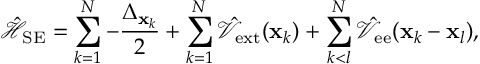Convert formula to latex. <formula><loc_0><loc_0><loc_500><loc_500>\hat { \mathcal { H } } _ { S E } = \sum _ { k = 1 } ^ { N } { - \frac { \Delta _ { { x } _ { k } } } { 2 } } + \sum _ { k = 1 } ^ { N } { \hat { \mathcal { V } } _ { e x t } ( { x } _ { k } ) } + \sum _ { k < l } ^ { N } { \hat { \mathcal { V } } _ { e e } ( { x } _ { k } - { x } _ { l } ) } ,</formula> 